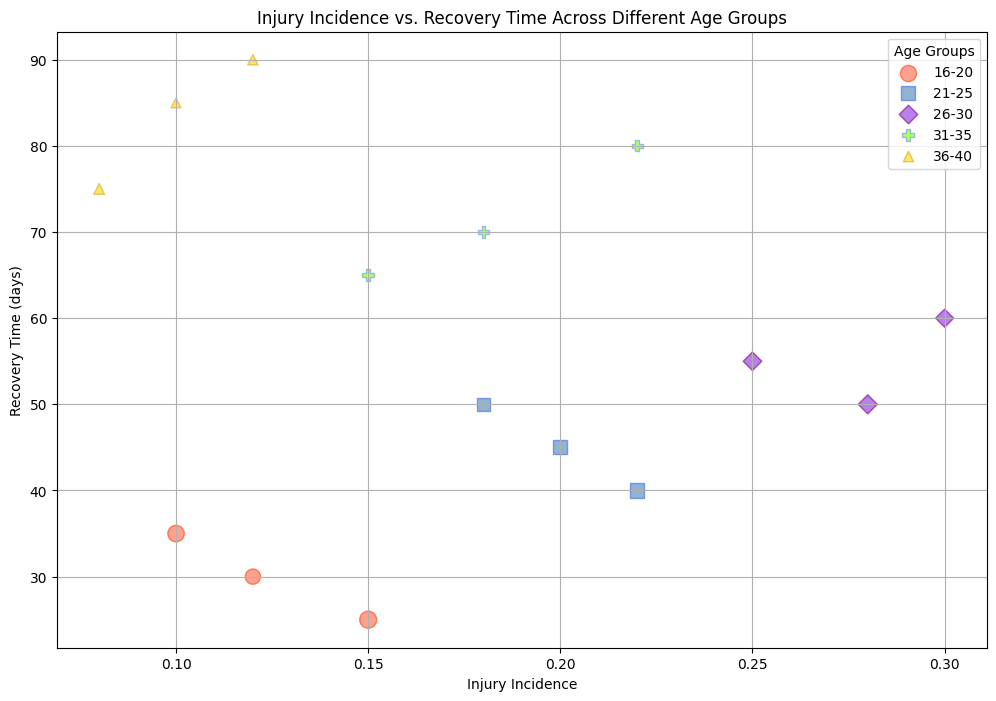What is the age group with the highest injury incidence? The age group with the highest injury incidence needs to be identified by comparing the injury incidence rates of all age groups. According to the chart, the 26-30 age group has the highest injury incidence rates (0.25, 0.30, and 0.28).
Answer: 26-30 Which age group tends to have the longest recovery times? To determine the age group with the longest recovery times, compare the recovery times of all age groups. The 36-40 age group has the longest recovery times (85, 90, and 75 days).
Answer: 36-40 How does the injury incidence for the 16-20 age group compare to the 21-25 age group? By comparing the injury incidence rates, the 16-20 age group has lower rates (0.12, 0.15, 0.10) compared to the 21-25 age group (0.20, 0.22, 0.18).
Answer: Lower What is the average recovery time for the 21-25 age group? Calculate the average recovery time by summing up the recovery times (45 + 40 + 50) and dividing by the number of values (3). The sum is 135 days, so 135 / 3 = 45 days.
Answer: 45 days How do the number of athletes influence the bubble size in the chart? The bubble size in the chart is proportional to the number of athletes. Larger bubbles represent larger numbers of athletes, as seen by comparing bubbles sizes across different age groups.
Answer: Directly proportional Which age group has the smallest variation in injury incidence? The 16-20 age group's injury incidence values (0.12, 0.15, 0.10) have smaller variation compared to other age groups. Perform visual inspection to confirm this.
Answer: 16-20 In which age group is the largest number of athletes found? The 16-20 age group has the largest number of athletes, with values 120, 150, and 140 represented by the largest bubble sizes.
Answer: 16-20 Which age group has a higher recovery time, the 26-30 or 31-35 age group? Compare the recovery times of both age groups. The 26-30 age group has 55, 60, and 50 days, while the 31-35 group has 70, 65, and 80 days, so the 31-35 group has consistently higher recovery times.
Answer: 31-35 What is the lowest injury incidence observed in the entire chart, and for which age group does it occur? The lowest injury incidence is identified by finding the minimum value in the entire dataset. It is 0.08, observed in the 36-40 age group.
Answer: 0.08, 36-40 